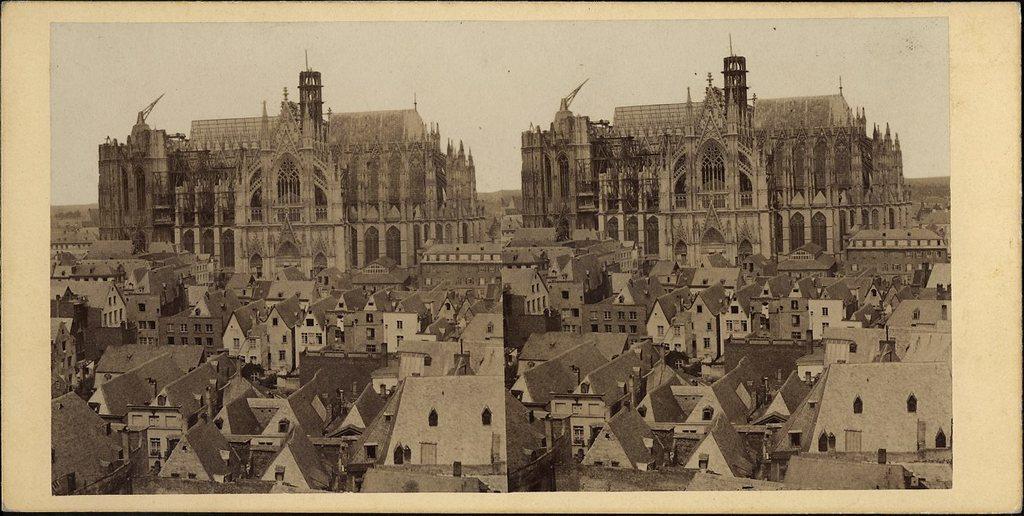Could you give a brief overview of what you see in this image? This is a collage of two images. In both images there are buildings with windows. In the back there is sky. 